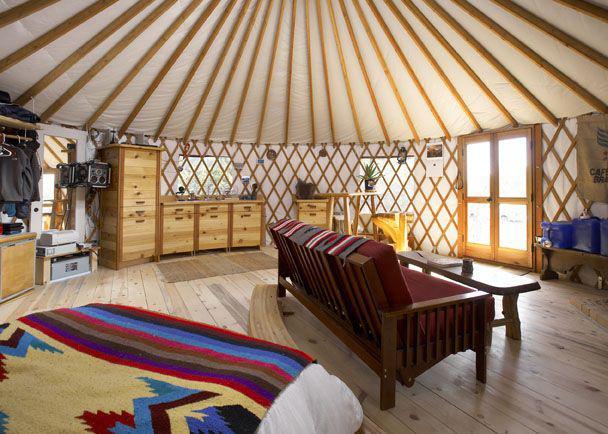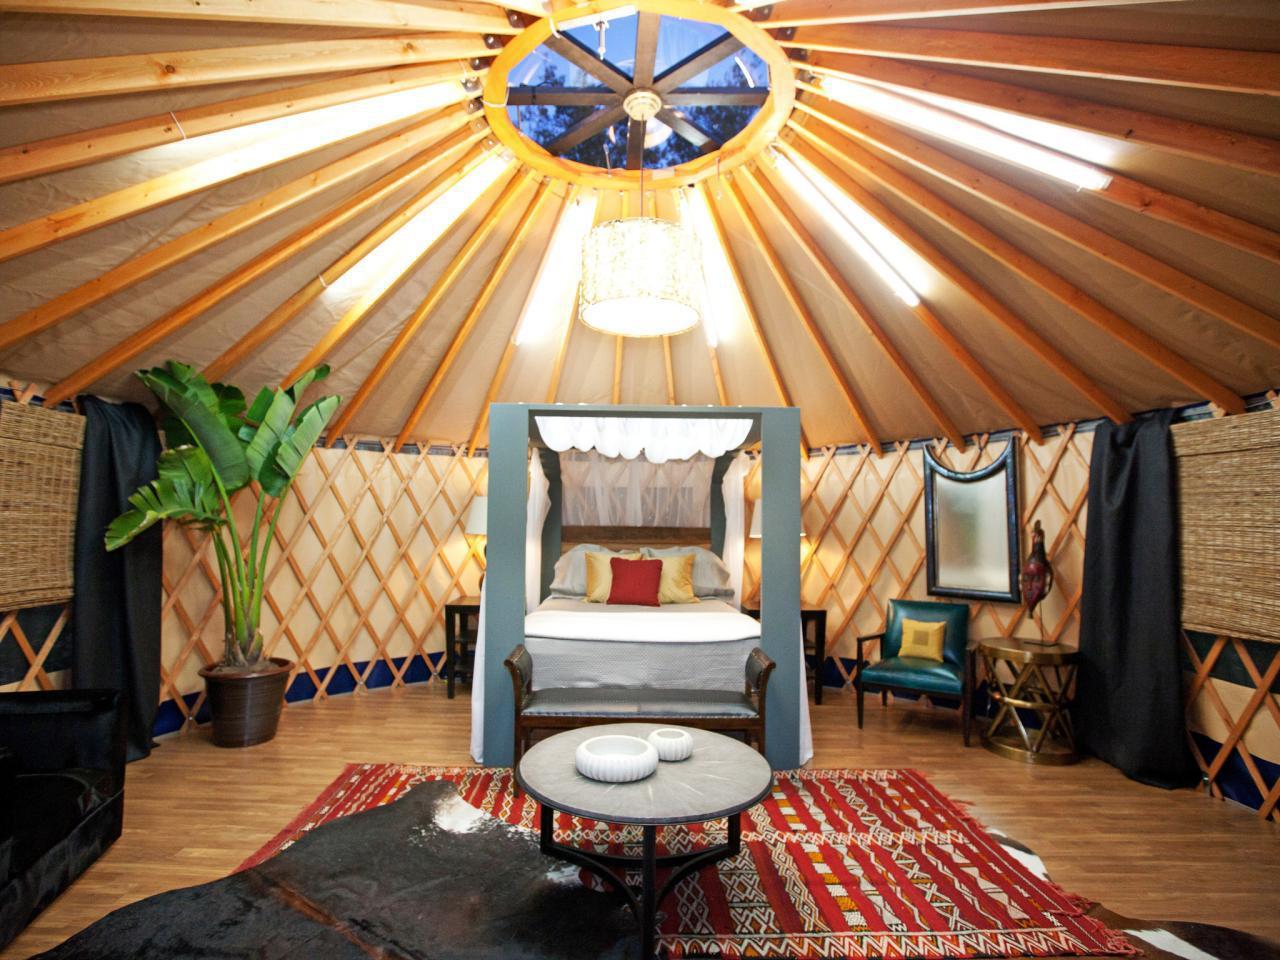The first image is the image on the left, the second image is the image on the right. Assess this claim about the two images: "At least one table is at the foot of the bed.". Correct or not? Answer yes or no. Yes. The first image is the image on the left, the second image is the image on the right. Assess this claim about the two images: "Both images are inside a yurt and the table in one of them is on top of a rug.". Correct or not? Answer yes or no. Yes. 